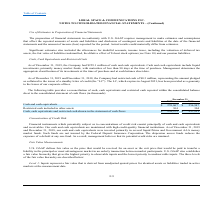From Loral Space Communications's financial document, What are the respective cash and cash equivalents in 2018 and 2019? The document shows two values: $256,947 and $259,067 (in thousands). From the document: "Cash and cash equivalents $ 259,067 $ 256,947 Cash and cash equivalents $ 259,067 $ 256,947..." Also, What are the respective restricted cash included in other assets in 2018 and 2019? The document shows two values: 304 and 304 (in thousands). From the document: "Restricted cash included in other assets 304 304..." Also, What are the respective cash, cash equivalents and restricted cash shown in the statement of cash flows in 2018 and 2019? The document shows two values: $257,251 and $259,371 (in thousands). From the document: "shown in the statement of cash flows $ 259,371 $ 257,251 icted cash shown in the statement of cash flows $ 259,371 $ 257,251..." Also, can you calculate: What is the average cash and cash equivalents in 2018 and 2019? To answer this question, I need to perform calculations using the financial data. The calculation is: ($259,067 + $256,947)/2 , which equals 258007 (in thousands). This is based on the information: "Cash and cash equivalents $ 259,067 $ 256,947 Cash and cash equivalents $ 259,067 $ 256,947..." The key data points involved are: 256,947, 259,067. Also, can you calculate: What is the percentage change in cash and cash equivalents between 2018 and 2019? To answer this question, I need to perform calculations using the financial data. The calculation is: (259,067 - 256,947)/256,947 , which equals 0.83 (percentage). This is based on the information: "Cash and cash equivalents $ 259,067 $ 256,947 Cash and cash equivalents $ 259,067 $ 256,947..." The key data points involved are: 256,947, 259,067. Also, can you calculate: What is the percentage change in the cash, cash equivalents and restricted cash shown in the statement of cash flows between 2018 and 2019? To answer this question, I need to perform calculations using the financial data. The calculation is: (259,371 - 257,251)/257,251 , which equals 0.82 (percentage). This is based on the information: "icted cash shown in the statement of cash flows $ 259,371 $ 257,251 shown in the statement of cash flows $ 259,371 $ 257,251..." The key data points involved are: 257,251, 259,371. 